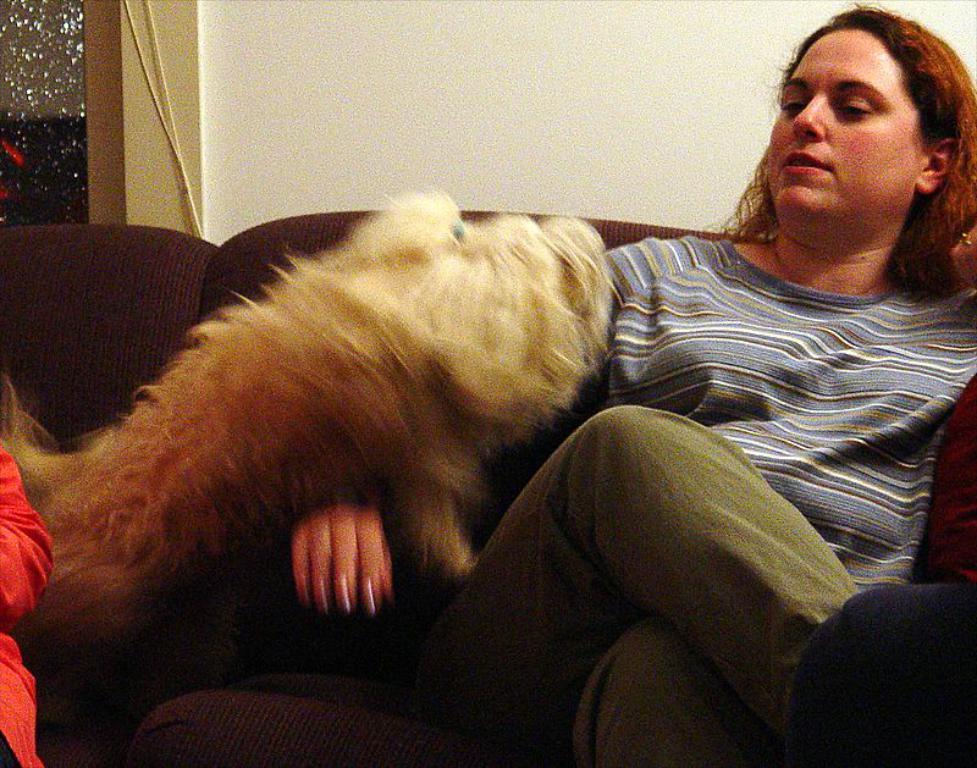How would you summarize this image in a sentence or two? here in this picture we can see woman sitting on a sofa ,with a dog on her right hand. 